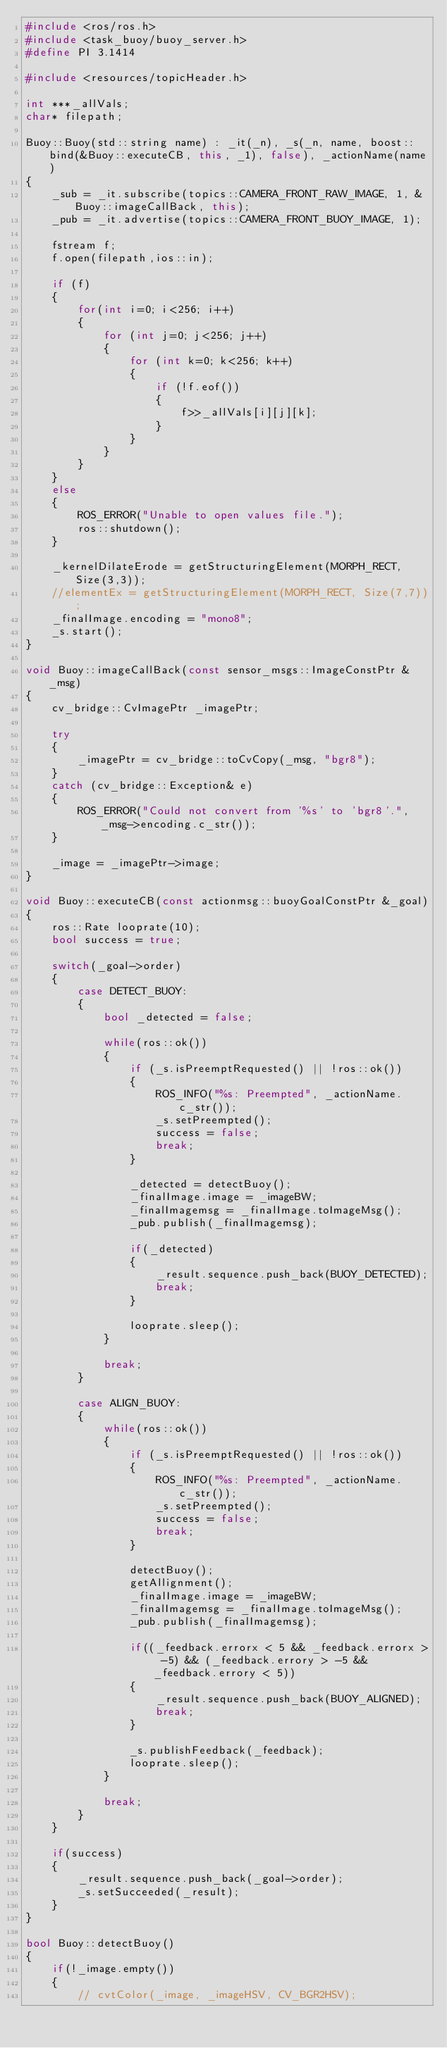<code> <loc_0><loc_0><loc_500><loc_500><_C++_>#include <ros/ros.h>
#include <task_buoy/buoy_server.h>
#define PI 3.1414

#include <resources/topicHeader.h>

int ***_allVals;
char* filepath;

Buoy::Buoy(std::string name) : _it(_n), _s(_n, name, boost::bind(&Buoy::executeCB, this, _1), false), _actionName(name)
{
    _sub = _it.subscribe(topics::CAMERA_FRONT_RAW_IMAGE, 1, &Buoy::imageCallBack, this);
    _pub = _it.advertise(topics::CAMERA_FRONT_BUOY_IMAGE, 1);

    fstream f;
    f.open(filepath,ios::in);

    if (f)
    {
        for(int i=0; i<256; i++)
        {
            for (int j=0; j<256; j++)
            {
                for (int k=0; k<256; k++)
                {
                    if (!f.eof())
                    {
                        f>>_allVals[i][j][k];
                    }
                }
            }
        }
    }
    else
    {
        ROS_ERROR("Unable to open values file.");
        ros::shutdown();
    }

    _kernelDilateErode = getStructuringElement(MORPH_RECT, Size(3,3));
    //elementEx = getStructuringElement(MORPH_RECT, Size(7,7));
    _finalImage.encoding = "mono8";
    _s.start();
}

void Buoy::imageCallBack(const sensor_msgs::ImageConstPtr &_msg)
{
    cv_bridge::CvImagePtr _imagePtr;

    try
    {
        _imagePtr = cv_bridge::toCvCopy(_msg, "bgr8");
    }
    catch (cv_bridge::Exception& e)
    {
        ROS_ERROR("Could not convert from '%s' to 'bgr8'.", _msg->encoding.c_str());
    }

    _image = _imagePtr->image;
}

void Buoy::executeCB(const actionmsg::buoyGoalConstPtr &_goal)
{
    ros::Rate looprate(10);
    bool success = true;

    switch(_goal->order)
    {
        case DETECT_BUOY:
        {
            bool _detected = false;

            while(ros::ok())
            {
                if (_s.isPreemptRequested() || !ros::ok())
                {
                    ROS_INFO("%s: Preempted", _actionName.c_str());
                    _s.setPreempted();
                    success = false;
                    break;
                }

                _detected = detectBuoy();
                _finalImage.image = _imageBW;
                _finalImagemsg = _finalImage.toImageMsg();
                _pub.publish(_finalImagemsg);

                if(_detected)
                {
                    _result.sequence.push_back(BUOY_DETECTED);
                    break;
                }

                looprate.sleep();
            }

            break;
        }

        case ALIGN_BUOY:
        {
            while(ros::ok())
            {
                if (_s.isPreemptRequested() || !ros::ok())
                {
                    ROS_INFO("%s: Preempted", _actionName.c_str());
                    _s.setPreempted();
                    success = false;
                    break;
                }

                detectBuoy();
                getAllignment();
                _finalImage.image = _imageBW;
                _finalImagemsg = _finalImage.toImageMsg();
                _pub.publish(_finalImagemsg);

                if((_feedback.errorx < 5 && _feedback.errorx > -5) && (_feedback.errory > -5 && _feedback.errory < 5))
                {
                    _result.sequence.push_back(BUOY_ALIGNED);
                    break;
                }

                _s.publishFeedback(_feedback);
                looprate.sleep();
            }

            break;
        }
    }

    if(success)
    {
        _result.sequence.push_back(_goal->order);
        _s.setSucceeded(_result);
    }
}

bool Buoy::detectBuoy()
{
    if(!_image.empty())
    {
        // cvtColor(_image, _imageHSV, CV_BGR2HSV);</code> 